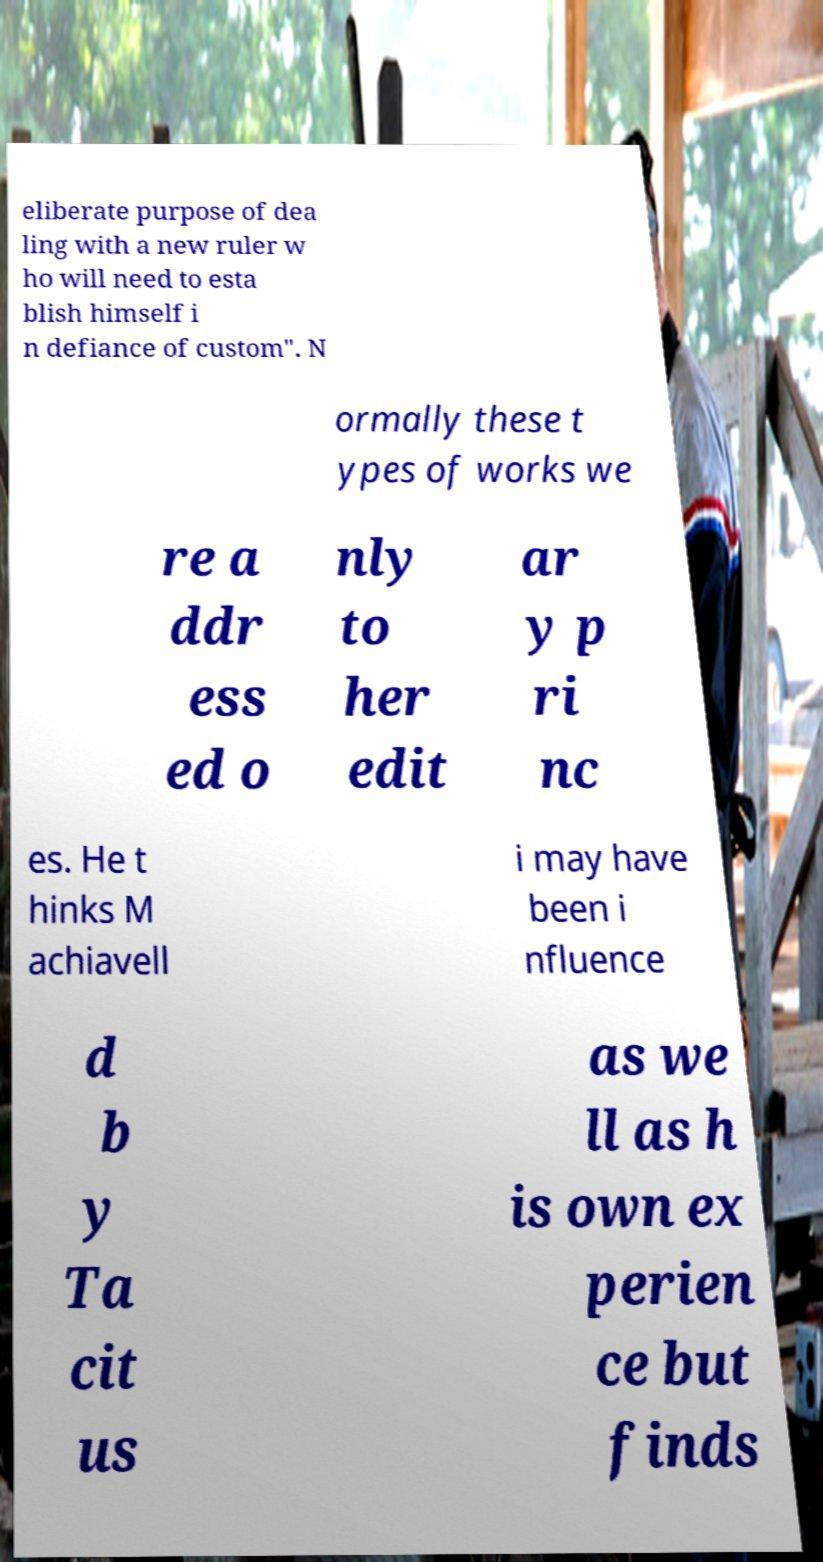There's text embedded in this image that I need extracted. Can you transcribe it verbatim? eliberate purpose of dea ling with a new ruler w ho will need to esta blish himself i n defiance of custom". N ormally these t ypes of works we re a ddr ess ed o nly to her edit ar y p ri nc es. He t hinks M achiavell i may have been i nfluence d b y Ta cit us as we ll as h is own ex perien ce but finds 